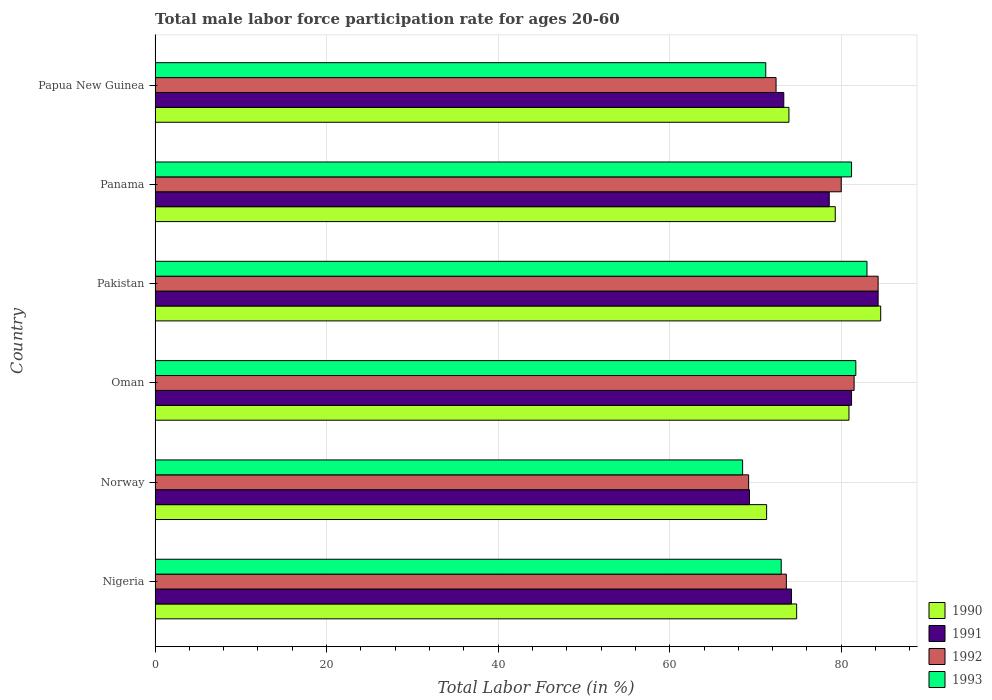Are the number of bars per tick equal to the number of legend labels?
Give a very brief answer. Yes. What is the label of the 4th group of bars from the top?
Your answer should be compact. Oman. What is the male labor force participation rate in 1991 in Norway?
Offer a very short reply. 69.3. Across all countries, what is the maximum male labor force participation rate in 1992?
Offer a terse response. 84.3. Across all countries, what is the minimum male labor force participation rate in 1993?
Offer a very short reply. 68.5. In which country was the male labor force participation rate in 1991 maximum?
Provide a succinct answer. Pakistan. In which country was the male labor force participation rate in 1990 minimum?
Your response must be concise. Norway. What is the total male labor force participation rate in 1990 in the graph?
Offer a terse response. 464.8. What is the difference between the male labor force participation rate in 1991 in Nigeria and that in Papua New Guinea?
Ensure brevity in your answer.  0.9. What is the difference between the male labor force participation rate in 1992 in Nigeria and the male labor force participation rate in 1993 in Oman?
Keep it short and to the point. -8.1. What is the average male labor force participation rate in 1990 per country?
Make the answer very short. 77.47. What is the difference between the male labor force participation rate in 1990 and male labor force participation rate in 1992 in Nigeria?
Make the answer very short. 1.2. What is the ratio of the male labor force participation rate in 1993 in Norway to that in Panama?
Ensure brevity in your answer.  0.84. Is the difference between the male labor force participation rate in 1990 in Norway and Panama greater than the difference between the male labor force participation rate in 1992 in Norway and Panama?
Keep it short and to the point. Yes. What is the difference between the highest and the second highest male labor force participation rate in 1991?
Offer a terse response. 3.1. In how many countries, is the male labor force participation rate in 1992 greater than the average male labor force participation rate in 1992 taken over all countries?
Give a very brief answer. 3. Is it the case that in every country, the sum of the male labor force participation rate in 1991 and male labor force participation rate in 1993 is greater than the sum of male labor force participation rate in 1990 and male labor force participation rate in 1992?
Ensure brevity in your answer.  No. What does the 4th bar from the top in Pakistan represents?
Offer a very short reply. 1990. What does the 1st bar from the bottom in Pakistan represents?
Keep it short and to the point. 1990. How many countries are there in the graph?
Your answer should be very brief. 6. Are the values on the major ticks of X-axis written in scientific E-notation?
Ensure brevity in your answer.  No. Does the graph contain any zero values?
Your answer should be very brief. No. Does the graph contain grids?
Your response must be concise. Yes. What is the title of the graph?
Ensure brevity in your answer.  Total male labor force participation rate for ages 20-60. What is the label or title of the X-axis?
Provide a succinct answer. Total Labor Force (in %). What is the label or title of the Y-axis?
Your response must be concise. Country. What is the Total Labor Force (in %) of 1990 in Nigeria?
Offer a very short reply. 74.8. What is the Total Labor Force (in %) in 1991 in Nigeria?
Keep it short and to the point. 74.2. What is the Total Labor Force (in %) of 1992 in Nigeria?
Provide a short and direct response. 73.6. What is the Total Labor Force (in %) of 1990 in Norway?
Keep it short and to the point. 71.3. What is the Total Labor Force (in %) in 1991 in Norway?
Your response must be concise. 69.3. What is the Total Labor Force (in %) in 1992 in Norway?
Your response must be concise. 69.2. What is the Total Labor Force (in %) of 1993 in Norway?
Your answer should be compact. 68.5. What is the Total Labor Force (in %) of 1990 in Oman?
Ensure brevity in your answer.  80.9. What is the Total Labor Force (in %) in 1991 in Oman?
Keep it short and to the point. 81.2. What is the Total Labor Force (in %) in 1992 in Oman?
Your response must be concise. 81.5. What is the Total Labor Force (in %) of 1993 in Oman?
Your answer should be compact. 81.7. What is the Total Labor Force (in %) in 1990 in Pakistan?
Offer a terse response. 84.6. What is the Total Labor Force (in %) of 1991 in Pakistan?
Make the answer very short. 84.3. What is the Total Labor Force (in %) of 1992 in Pakistan?
Ensure brevity in your answer.  84.3. What is the Total Labor Force (in %) of 1993 in Pakistan?
Your response must be concise. 83. What is the Total Labor Force (in %) in 1990 in Panama?
Provide a succinct answer. 79.3. What is the Total Labor Force (in %) of 1991 in Panama?
Provide a short and direct response. 78.6. What is the Total Labor Force (in %) in 1992 in Panama?
Give a very brief answer. 80. What is the Total Labor Force (in %) of 1993 in Panama?
Provide a short and direct response. 81.2. What is the Total Labor Force (in %) in 1990 in Papua New Guinea?
Your response must be concise. 73.9. What is the Total Labor Force (in %) in 1991 in Papua New Guinea?
Provide a succinct answer. 73.3. What is the Total Labor Force (in %) of 1992 in Papua New Guinea?
Ensure brevity in your answer.  72.4. What is the Total Labor Force (in %) in 1993 in Papua New Guinea?
Give a very brief answer. 71.2. Across all countries, what is the maximum Total Labor Force (in %) of 1990?
Provide a succinct answer. 84.6. Across all countries, what is the maximum Total Labor Force (in %) of 1991?
Keep it short and to the point. 84.3. Across all countries, what is the maximum Total Labor Force (in %) of 1992?
Make the answer very short. 84.3. Across all countries, what is the maximum Total Labor Force (in %) of 1993?
Your answer should be compact. 83. Across all countries, what is the minimum Total Labor Force (in %) of 1990?
Keep it short and to the point. 71.3. Across all countries, what is the minimum Total Labor Force (in %) of 1991?
Your answer should be compact. 69.3. Across all countries, what is the minimum Total Labor Force (in %) in 1992?
Provide a succinct answer. 69.2. Across all countries, what is the minimum Total Labor Force (in %) in 1993?
Offer a very short reply. 68.5. What is the total Total Labor Force (in %) in 1990 in the graph?
Provide a short and direct response. 464.8. What is the total Total Labor Force (in %) of 1991 in the graph?
Give a very brief answer. 460.9. What is the total Total Labor Force (in %) in 1992 in the graph?
Your response must be concise. 461. What is the total Total Labor Force (in %) in 1993 in the graph?
Keep it short and to the point. 458.6. What is the difference between the Total Labor Force (in %) of 1991 in Nigeria and that in Norway?
Make the answer very short. 4.9. What is the difference between the Total Labor Force (in %) of 1993 in Nigeria and that in Norway?
Give a very brief answer. 4.5. What is the difference between the Total Labor Force (in %) of 1991 in Nigeria and that in Oman?
Provide a succinct answer. -7. What is the difference between the Total Labor Force (in %) of 1992 in Nigeria and that in Oman?
Provide a succinct answer. -7.9. What is the difference between the Total Labor Force (in %) in 1993 in Nigeria and that in Oman?
Offer a terse response. -8.7. What is the difference between the Total Labor Force (in %) in 1990 in Nigeria and that in Pakistan?
Provide a short and direct response. -9.8. What is the difference between the Total Labor Force (in %) in 1992 in Nigeria and that in Pakistan?
Keep it short and to the point. -10.7. What is the difference between the Total Labor Force (in %) in 1990 in Nigeria and that in Panama?
Your answer should be compact. -4.5. What is the difference between the Total Labor Force (in %) in 1991 in Nigeria and that in Panama?
Provide a succinct answer. -4.4. What is the difference between the Total Labor Force (in %) in 1991 in Nigeria and that in Papua New Guinea?
Give a very brief answer. 0.9. What is the difference between the Total Labor Force (in %) in 1992 in Norway and that in Oman?
Keep it short and to the point. -12.3. What is the difference between the Total Labor Force (in %) in 1991 in Norway and that in Pakistan?
Give a very brief answer. -15. What is the difference between the Total Labor Force (in %) in 1992 in Norway and that in Pakistan?
Give a very brief answer. -15.1. What is the difference between the Total Labor Force (in %) in 1992 in Norway and that in Panama?
Ensure brevity in your answer.  -10.8. What is the difference between the Total Labor Force (in %) of 1993 in Norway and that in Panama?
Provide a succinct answer. -12.7. What is the difference between the Total Labor Force (in %) of 1990 in Norway and that in Papua New Guinea?
Your response must be concise. -2.6. What is the difference between the Total Labor Force (in %) of 1991 in Norway and that in Papua New Guinea?
Make the answer very short. -4. What is the difference between the Total Labor Force (in %) in 1993 in Norway and that in Papua New Guinea?
Offer a terse response. -2.7. What is the difference between the Total Labor Force (in %) of 1990 in Oman and that in Pakistan?
Make the answer very short. -3.7. What is the difference between the Total Labor Force (in %) in 1990 in Oman and that in Panama?
Your response must be concise. 1.6. What is the difference between the Total Labor Force (in %) in 1993 in Oman and that in Panama?
Provide a succinct answer. 0.5. What is the difference between the Total Labor Force (in %) of 1990 in Oman and that in Papua New Guinea?
Your response must be concise. 7. What is the difference between the Total Labor Force (in %) of 1993 in Oman and that in Papua New Guinea?
Provide a short and direct response. 10.5. What is the difference between the Total Labor Force (in %) in 1992 in Pakistan and that in Panama?
Offer a terse response. 4.3. What is the difference between the Total Labor Force (in %) of 1993 in Pakistan and that in Papua New Guinea?
Your answer should be compact. 11.8. What is the difference between the Total Labor Force (in %) in 1993 in Panama and that in Papua New Guinea?
Offer a very short reply. 10. What is the difference between the Total Labor Force (in %) of 1990 in Nigeria and the Total Labor Force (in %) of 1992 in Norway?
Your answer should be very brief. 5.6. What is the difference between the Total Labor Force (in %) in 1990 in Nigeria and the Total Labor Force (in %) in 1993 in Norway?
Provide a short and direct response. 6.3. What is the difference between the Total Labor Force (in %) of 1991 in Nigeria and the Total Labor Force (in %) of 1993 in Norway?
Provide a short and direct response. 5.7. What is the difference between the Total Labor Force (in %) in 1990 in Nigeria and the Total Labor Force (in %) in 1991 in Oman?
Give a very brief answer. -6.4. What is the difference between the Total Labor Force (in %) in 1990 in Nigeria and the Total Labor Force (in %) in 1992 in Oman?
Offer a very short reply. -6.7. What is the difference between the Total Labor Force (in %) of 1991 in Nigeria and the Total Labor Force (in %) of 1993 in Pakistan?
Your answer should be compact. -8.8. What is the difference between the Total Labor Force (in %) of 1992 in Nigeria and the Total Labor Force (in %) of 1993 in Pakistan?
Make the answer very short. -9.4. What is the difference between the Total Labor Force (in %) in 1990 in Nigeria and the Total Labor Force (in %) in 1991 in Panama?
Give a very brief answer. -3.8. What is the difference between the Total Labor Force (in %) in 1990 in Nigeria and the Total Labor Force (in %) in 1991 in Papua New Guinea?
Your answer should be compact. 1.5. What is the difference between the Total Labor Force (in %) of 1990 in Nigeria and the Total Labor Force (in %) of 1992 in Papua New Guinea?
Your answer should be very brief. 2.4. What is the difference between the Total Labor Force (in %) of 1991 in Nigeria and the Total Labor Force (in %) of 1992 in Papua New Guinea?
Your response must be concise. 1.8. What is the difference between the Total Labor Force (in %) in 1991 in Nigeria and the Total Labor Force (in %) in 1993 in Papua New Guinea?
Your response must be concise. 3. What is the difference between the Total Labor Force (in %) in 1990 in Norway and the Total Labor Force (in %) in 1993 in Oman?
Keep it short and to the point. -10.4. What is the difference between the Total Labor Force (in %) in 1991 in Norway and the Total Labor Force (in %) in 1993 in Oman?
Provide a short and direct response. -12.4. What is the difference between the Total Labor Force (in %) in 1992 in Norway and the Total Labor Force (in %) in 1993 in Oman?
Offer a very short reply. -12.5. What is the difference between the Total Labor Force (in %) in 1991 in Norway and the Total Labor Force (in %) in 1993 in Pakistan?
Give a very brief answer. -13.7. What is the difference between the Total Labor Force (in %) of 1992 in Norway and the Total Labor Force (in %) of 1993 in Pakistan?
Keep it short and to the point. -13.8. What is the difference between the Total Labor Force (in %) of 1991 in Norway and the Total Labor Force (in %) of 1992 in Panama?
Give a very brief answer. -10.7. What is the difference between the Total Labor Force (in %) of 1990 in Norway and the Total Labor Force (in %) of 1991 in Papua New Guinea?
Ensure brevity in your answer.  -2. What is the difference between the Total Labor Force (in %) in 1991 in Norway and the Total Labor Force (in %) in 1992 in Papua New Guinea?
Provide a succinct answer. -3.1. What is the difference between the Total Labor Force (in %) of 1990 in Oman and the Total Labor Force (in %) of 1992 in Pakistan?
Offer a very short reply. -3.4. What is the difference between the Total Labor Force (in %) of 1991 in Oman and the Total Labor Force (in %) of 1993 in Panama?
Offer a very short reply. 0. What is the difference between the Total Labor Force (in %) of 1990 in Oman and the Total Labor Force (in %) of 1992 in Papua New Guinea?
Your answer should be compact. 8.5. What is the difference between the Total Labor Force (in %) of 1990 in Oman and the Total Labor Force (in %) of 1993 in Papua New Guinea?
Give a very brief answer. 9.7. What is the difference between the Total Labor Force (in %) in 1991 in Oman and the Total Labor Force (in %) in 1992 in Papua New Guinea?
Ensure brevity in your answer.  8.8. What is the difference between the Total Labor Force (in %) in 1992 in Pakistan and the Total Labor Force (in %) in 1993 in Panama?
Your response must be concise. 3.1. What is the difference between the Total Labor Force (in %) in 1990 in Pakistan and the Total Labor Force (in %) in 1992 in Papua New Guinea?
Offer a terse response. 12.2. What is the difference between the Total Labor Force (in %) in 1990 in Pakistan and the Total Labor Force (in %) in 1993 in Papua New Guinea?
Offer a terse response. 13.4. What is the difference between the Total Labor Force (in %) in 1991 in Pakistan and the Total Labor Force (in %) in 1992 in Papua New Guinea?
Give a very brief answer. 11.9. What is the difference between the Total Labor Force (in %) of 1991 in Pakistan and the Total Labor Force (in %) of 1993 in Papua New Guinea?
Offer a terse response. 13.1. What is the difference between the Total Labor Force (in %) in 1990 in Panama and the Total Labor Force (in %) in 1991 in Papua New Guinea?
Your answer should be compact. 6. What is the difference between the Total Labor Force (in %) of 1990 in Panama and the Total Labor Force (in %) of 1992 in Papua New Guinea?
Provide a short and direct response. 6.9. What is the difference between the Total Labor Force (in %) of 1990 in Panama and the Total Labor Force (in %) of 1993 in Papua New Guinea?
Your answer should be compact. 8.1. What is the difference between the Total Labor Force (in %) in 1991 in Panama and the Total Labor Force (in %) in 1992 in Papua New Guinea?
Offer a terse response. 6.2. What is the difference between the Total Labor Force (in %) of 1991 in Panama and the Total Labor Force (in %) of 1993 in Papua New Guinea?
Offer a terse response. 7.4. What is the average Total Labor Force (in %) in 1990 per country?
Make the answer very short. 77.47. What is the average Total Labor Force (in %) in 1991 per country?
Your answer should be very brief. 76.82. What is the average Total Labor Force (in %) in 1992 per country?
Offer a very short reply. 76.83. What is the average Total Labor Force (in %) of 1993 per country?
Offer a terse response. 76.43. What is the difference between the Total Labor Force (in %) in 1990 and Total Labor Force (in %) in 1991 in Nigeria?
Provide a short and direct response. 0.6. What is the difference between the Total Labor Force (in %) of 1990 and Total Labor Force (in %) of 1993 in Nigeria?
Offer a very short reply. 1.8. What is the difference between the Total Labor Force (in %) in 1990 and Total Labor Force (in %) in 1991 in Norway?
Keep it short and to the point. 2. What is the difference between the Total Labor Force (in %) of 1990 and Total Labor Force (in %) of 1993 in Norway?
Your answer should be compact. 2.8. What is the difference between the Total Labor Force (in %) of 1991 and Total Labor Force (in %) of 1993 in Norway?
Your answer should be very brief. 0.8. What is the difference between the Total Labor Force (in %) in 1992 and Total Labor Force (in %) in 1993 in Norway?
Ensure brevity in your answer.  0.7. What is the difference between the Total Labor Force (in %) in 1990 and Total Labor Force (in %) in 1992 in Oman?
Keep it short and to the point. -0.6. What is the difference between the Total Labor Force (in %) in 1990 and Total Labor Force (in %) in 1993 in Oman?
Provide a short and direct response. -0.8. What is the difference between the Total Labor Force (in %) in 1991 and Total Labor Force (in %) in 1992 in Oman?
Offer a very short reply. -0.3. What is the difference between the Total Labor Force (in %) in 1990 and Total Labor Force (in %) in 1991 in Pakistan?
Your response must be concise. 0.3. What is the difference between the Total Labor Force (in %) in 1990 and Total Labor Force (in %) in 1993 in Pakistan?
Your answer should be compact. 1.6. What is the difference between the Total Labor Force (in %) in 1991 and Total Labor Force (in %) in 1992 in Pakistan?
Provide a short and direct response. 0. What is the difference between the Total Labor Force (in %) of 1991 and Total Labor Force (in %) of 1993 in Pakistan?
Keep it short and to the point. 1.3. What is the difference between the Total Labor Force (in %) of 1992 and Total Labor Force (in %) of 1993 in Pakistan?
Ensure brevity in your answer.  1.3. What is the difference between the Total Labor Force (in %) of 1990 and Total Labor Force (in %) of 1991 in Panama?
Your answer should be compact. 0.7. What is the difference between the Total Labor Force (in %) of 1990 and Total Labor Force (in %) of 1992 in Papua New Guinea?
Make the answer very short. 1.5. What is the difference between the Total Labor Force (in %) in 1990 and Total Labor Force (in %) in 1993 in Papua New Guinea?
Offer a very short reply. 2.7. What is the difference between the Total Labor Force (in %) of 1992 and Total Labor Force (in %) of 1993 in Papua New Guinea?
Your response must be concise. 1.2. What is the ratio of the Total Labor Force (in %) of 1990 in Nigeria to that in Norway?
Make the answer very short. 1.05. What is the ratio of the Total Labor Force (in %) of 1991 in Nigeria to that in Norway?
Ensure brevity in your answer.  1.07. What is the ratio of the Total Labor Force (in %) of 1992 in Nigeria to that in Norway?
Offer a very short reply. 1.06. What is the ratio of the Total Labor Force (in %) in 1993 in Nigeria to that in Norway?
Provide a short and direct response. 1.07. What is the ratio of the Total Labor Force (in %) of 1990 in Nigeria to that in Oman?
Provide a short and direct response. 0.92. What is the ratio of the Total Labor Force (in %) in 1991 in Nigeria to that in Oman?
Ensure brevity in your answer.  0.91. What is the ratio of the Total Labor Force (in %) in 1992 in Nigeria to that in Oman?
Give a very brief answer. 0.9. What is the ratio of the Total Labor Force (in %) in 1993 in Nigeria to that in Oman?
Your answer should be compact. 0.89. What is the ratio of the Total Labor Force (in %) in 1990 in Nigeria to that in Pakistan?
Provide a succinct answer. 0.88. What is the ratio of the Total Labor Force (in %) in 1991 in Nigeria to that in Pakistan?
Your answer should be compact. 0.88. What is the ratio of the Total Labor Force (in %) in 1992 in Nigeria to that in Pakistan?
Provide a short and direct response. 0.87. What is the ratio of the Total Labor Force (in %) in 1993 in Nigeria to that in Pakistan?
Offer a terse response. 0.88. What is the ratio of the Total Labor Force (in %) of 1990 in Nigeria to that in Panama?
Offer a terse response. 0.94. What is the ratio of the Total Labor Force (in %) in 1991 in Nigeria to that in Panama?
Provide a short and direct response. 0.94. What is the ratio of the Total Labor Force (in %) of 1993 in Nigeria to that in Panama?
Keep it short and to the point. 0.9. What is the ratio of the Total Labor Force (in %) of 1990 in Nigeria to that in Papua New Guinea?
Your answer should be compact. 1.01. What is the ratio of the Total Labor Force (in %) of 1991 in Nigeria to that in Papua New Guinea?
Your response must be concise. 1.01. What is the ratio of the Total Labor Force (in %) of 1992 in Nigeria to that in Papua New Guinea?
Offer a very short reply. 1.02. What is the ratio of the Total Labor Force (in %) in 1993 in Nigeria to that in Papua New Guinea?
Your answer should be compact. 1.03. What is the ratio of the Total Labor Force (in %) of 1990 in Norway to that in Oman?
Provide a succinct answer. 0.88. What is the ratio of the Total Labor Force (in %) in 1991 in Norway to that in Oman?
Offer a very short reply. 0.85. What is the ratio of the Total Labor Force (in %) of 1992 in Norway to that in Oman?
Provide a short and direct response. 0.85. What is the ratio of the Total Labor Force (in %) of 1993 in Norway to that in Oman?
Provide a succinct answer. 0.84. What is the ratio of the Total Labor Force (in %) of 1990 in Norway to that in Pakistan?
Offer a very short reply. 0.84. What is the ratio of the Total Labor Force (in %) of 1991 in Norway to that in Pakistan?
Your answer should be very brief. 0.82. What is the ratio of the Total Labor Force (in %) of 1992 in Norway to that in Pakistan?
Make the answer very short. 0.82. What is the ratio of the Total Labor Force (in %) in 1993 in Norway to that in Pakistan?
Offer a very short reply. 0.83. What is the ratio of the Total Labor Force (in %) in 1990 in Norway to that in Panama?
Offer a terse response. 0.9. What is the ratio of the Total Labor Force (in %) in 1991 in Norway to that in Panama?
Provide a short and direct response. 0.88. What is the ratio of the Total Labor Force (in %) in 1992 in Norway to that in Panama?
Offer a very short reply. 0.86. What is the ratio of the Total Labor Force (in %) of 1993 in Norway to that in Panama?
Your answer should be compact. 0.84. What is the ratio of the Total Labor Force (in %) in 1990 in Norway to that in Papua New Guinea?
Give a very brief answer. 0.96. What is the ratio of the Total Labor Force (in %) of 1991 in Norway to that in Papua New Guinea?
Provide a succinct answer. 0.95. What is the ratio of the Total Labor Force (in %) of 1992 in Norway to that in Papua New Guinea?
Make the answer very short. 0.96. What is the ratio of the Total Labor Force (in %) of 1993 in Norway to that in Papua New Guinea?
Your answer should be very brief. 0.96. What is the ratio of the Total Labor Force (in %) of 1990 in Oman to that in Pakistan?
Your answer should be very brief. 0.96. What is the ratio of the Total Labor Force (in %) of 1991 in Oman to that in Pakistan?
Your response must be concise. 0.96. What is the ratio of the Total Labor Force (in %) in 1992 in Oman to that in Pakistan?
Keep it short and to the point. 0.97. What is the ratio of the Total Labor Force (in %) of 1993 in Oman to that in Pakistan?
Keep it short and to the point. 0.98. What is the ratio of the Total Labor Force (in %) in 1990 in Oman to that in Panama?
Ensure brevity in your answer.  1.02. What is the ratio of the Total Labor Force (in %) in 1991 in Oman to that in Panama?
Offer a terse response. 1.03. What is the ratio of the Total Labor Force (in %) in 1992 in Oman to that in Panama?
Give a very brief answer. 1.02. What is the ratio of the Total Labor Force (in %) in 1993 in Oman to that in Panama?
Keep it short and to the point. 1.01. What is the ratio of the Total Labor Force (in %) of 1990 in Oman to that in Papua New Guinea?
Your answer should be very brief. 1.09. What is the ratio of the Total Labor Force (in %) in 1991 in Oman to that in Papua New Guinea?
Keep it short and to the point. 1.11. What is the ratio of the Total Labor Force (in %) in 1992 in Oman to that in Papua New Guinea?
Keep it short and to the point. 1.13. What is the ratio of the Total Labor Force (in %) in 1993 in Oman to that in Papua New Guinea?
Keep it short and to the point. 1.15. What is the ratio of the Total Labor Force (in %) in 1990 in Pakistan to that in Panama?
Your answer should be compact. 1.07. What is the ratio of the Total Labor Force (in %) in 1991 in Pakistan to that in Panama?
Provide a succinct answer. 1.07. What is the ratio of the Total Labor Force (in %) of 1992 in Pakistan to that in Panama?
Your response must be concise. 1.05. What is the ratio of the Total Labor Force (in %) in 1993 in Pakistan to that in Panama?
Provide a succinct answer. 1.02. What is the ratio of the Total Labor Force (in %) in 1990 in Pakistan to that in Papua New Guinea?
Make the answer very short. 1.14. What is the ratio of the Total Labor Force (in %) of 1991 in Pakistan to that in Papua New Guinea?
Your answer should be very brief. 1.15. What is the ratio of the Total Labor Force (in %) of 1992 in Pakistan to that in Papua New Guinea?
Provide a succinct answer. 1.16. What is the ratio of the Total Labor Force (in %) of 1993 in Pakistan to that in Papua New Guinea?
Offer a very short reply. 1.17. What is the ratio of the Total Labor Force (in %) in 1990 in Panama to that in Papua New Guinea?
Your response must be concise. 1.07. What is the ratio of the Total Labor Force (in %) in 1991 in Panama to that in Papua New Guinea?
Your answer should be very brief. 1.07. What is the ratio of the Total Labor Force (in %) of 1992 in Panama to that in Papua New Guinea?
Offer a terse response. 1.1. What is the ratio of the Total Labor Force (in %) in 1993 in Panama to that in Papua New Guinea?
Offer a terse response. 1.14. What is the difference between the highest and the second highest Total Labor Force (in %) in 1993?
Provide a short and direct response. 1.3. What is the difference between the highest and the lowest Total Labor Force (in %) in 1991?
Provide a short and direct response. 15. What is the difference between the highest and the lowest Total Labor Force (in %) in 1992?
Keep it short and to the point. 15.1. 